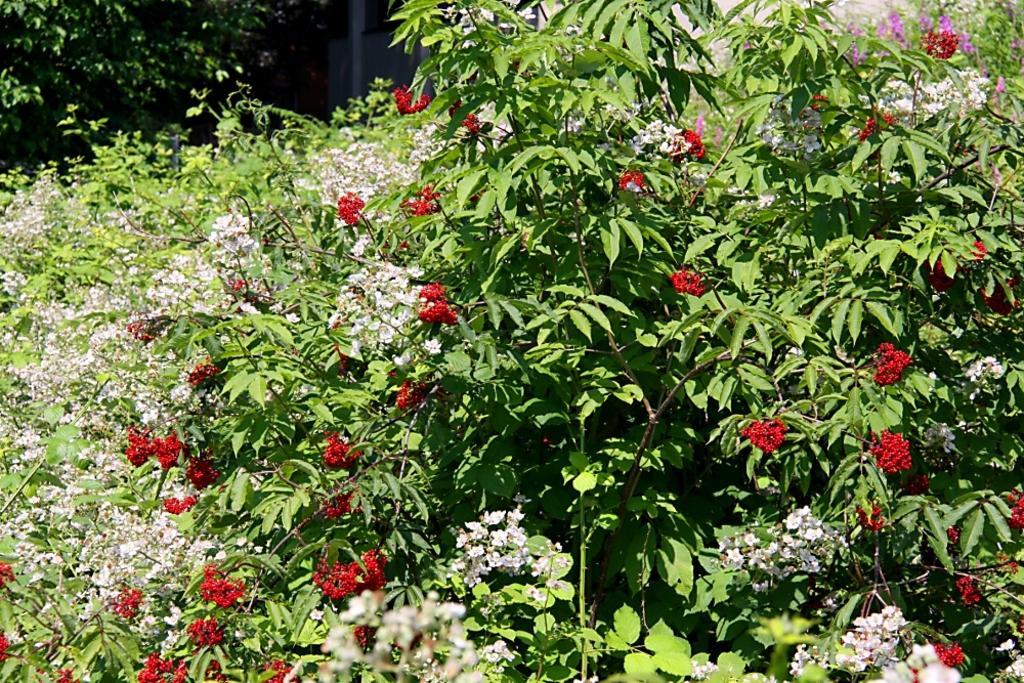Describe this image in one or two sentences. In this image, we can see there are plants having flowers and green color leaves. In the background, there are branches of a tree having green color leaves and there is a wall. 